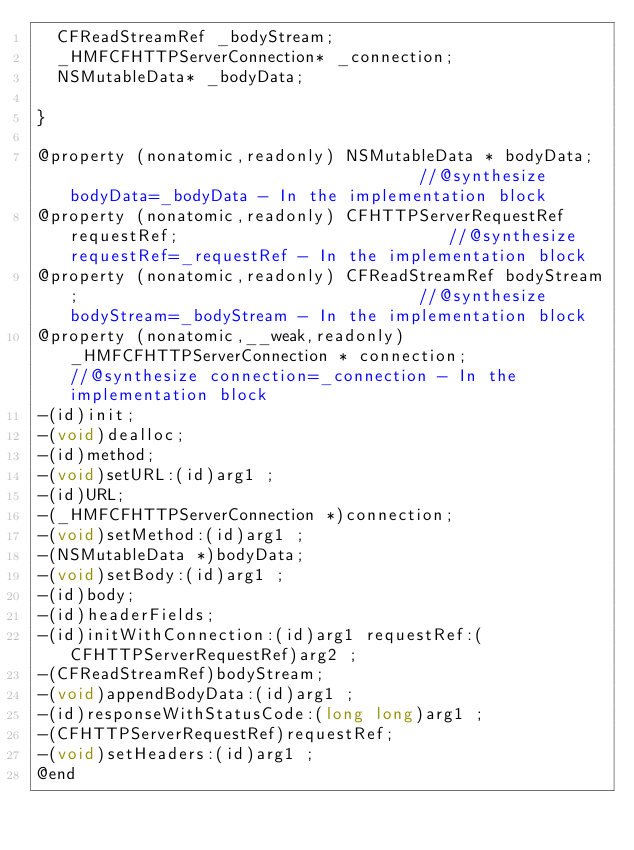<code> <loc_0><loc_0><loc_500><loc_500><_C_>	CFReadStreamRef _bodyStream;
	_HMFCFHTTPServerConnection* _connection;
	NSMutableData* _bodyData;

}

@property (nonatomic,readonly) NSMutableData * bodyData;                                    //@synthesize bodyData=_bodyData - In the implementation block
@property (nonatomic,readonly) CFHTTPServerRequestRef requestRef;                           //@synthesize requestRef=_requestRef - In the implementation block
@property (nonatomic,readonly) CFReadStreamRef bodyStream;                                  //@synthesize bodyStream=_bodyStream - In the implementation block
@property (nonatomic,__weak,readonly) _HMFCFHTTPServerConnection * connection;              //@synthesize connection=_connection - In the implementation block
-(id)init;
-(void)dealloc;
-(id)method;
-(void)setURL:(id)arg1 ;
-(id)URL;
-(_HMFCFHTTPServerConnection *)connection;
-(void)setMethod:(id)arg1 ;
-(NSMutableData *)bodyData;
-(void)setBody:(id)arg1 ;
-(id)body;
-(id)headerFields;
-(id)initWithConnection:(id)arg1 requestRef:(CFHTTPServerRequestRef)arg2 ;
-(CFReadStreamRef)bodyStream;
-(void)appendBodyData:(id)arg1 ;
-(id)responseWithStatusCode:(long long)arg1 ;
-(CFHTTPServerRequestRef)requestRef;
-(void)setHeaders:(id)arg1 ;
@end

</code> 